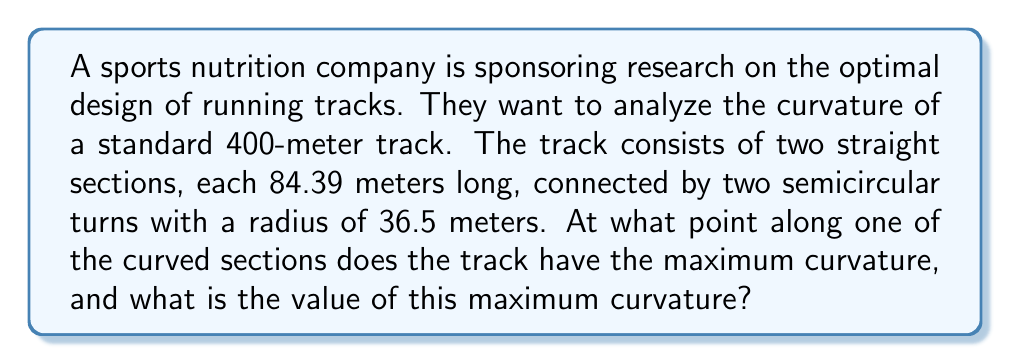Solve this math problem. To solve this problem, we'll use concepts from differential geometry:

1) First, let's consider the parametric equations for a semicircle:
   $$x = r\cos(\theta)$$
   $$y = r\sin(\theta)$$
   where $r = 36.5$ meters and $0 \leq \theta \leq \pi$

2) The curvature $\kappa$ of a curve in parametric form is given by:
   $$\kappa = \frac{|x'y'' - y'x''|}{(x'^2 + y'^2)^{3/2}}$$

3) Let's calculate the first and second derivatives:
   $$x' = -r\sin(\theta)$$
   $$y' = r\cos(\theta)$$
   $$x'' = -r\cos(\theta)$$
   $$y'' = -r\sin(\theta)$$

4) Substituting these into the curvature formula:
   $$\kappa = \frac{|(-r\sin(\theta))(-r\sin(\theta)) - (r\cos(\theta))(-r\cos(\theta))|}{(r^2\sin^2(\theta) + r^2\cos^2(\theta))^{3/2}}$$

5) Simplify:
   $$\kappa = \frac{r(\sin^2(\theta) + \cos^2(\theta))}{r^3(\sin^2(\theta) + \cos^2(\theta))^{3/2}}$$

6) Using the identity $\sin^2(\theta) + \cos^2(\theta) = 1$, we get:
   $$\kappa = \frac{r}{r^3} = \frac{1}{r}$$

7) This shows that the curvature is constant along the entire semicircular section, with a value of:
   $$\kappa = \frac{1}{36.5} \approx 0.0274$$ per meter

8) The straight sections have zero curvature, so the maximum curvature occurs throughout the curved sections.
Answer: The maximum curvature occurs at all points along the curved sections of the track and has a value of $\frac{1}{36.5} \approx 0.0274$ per meter. 